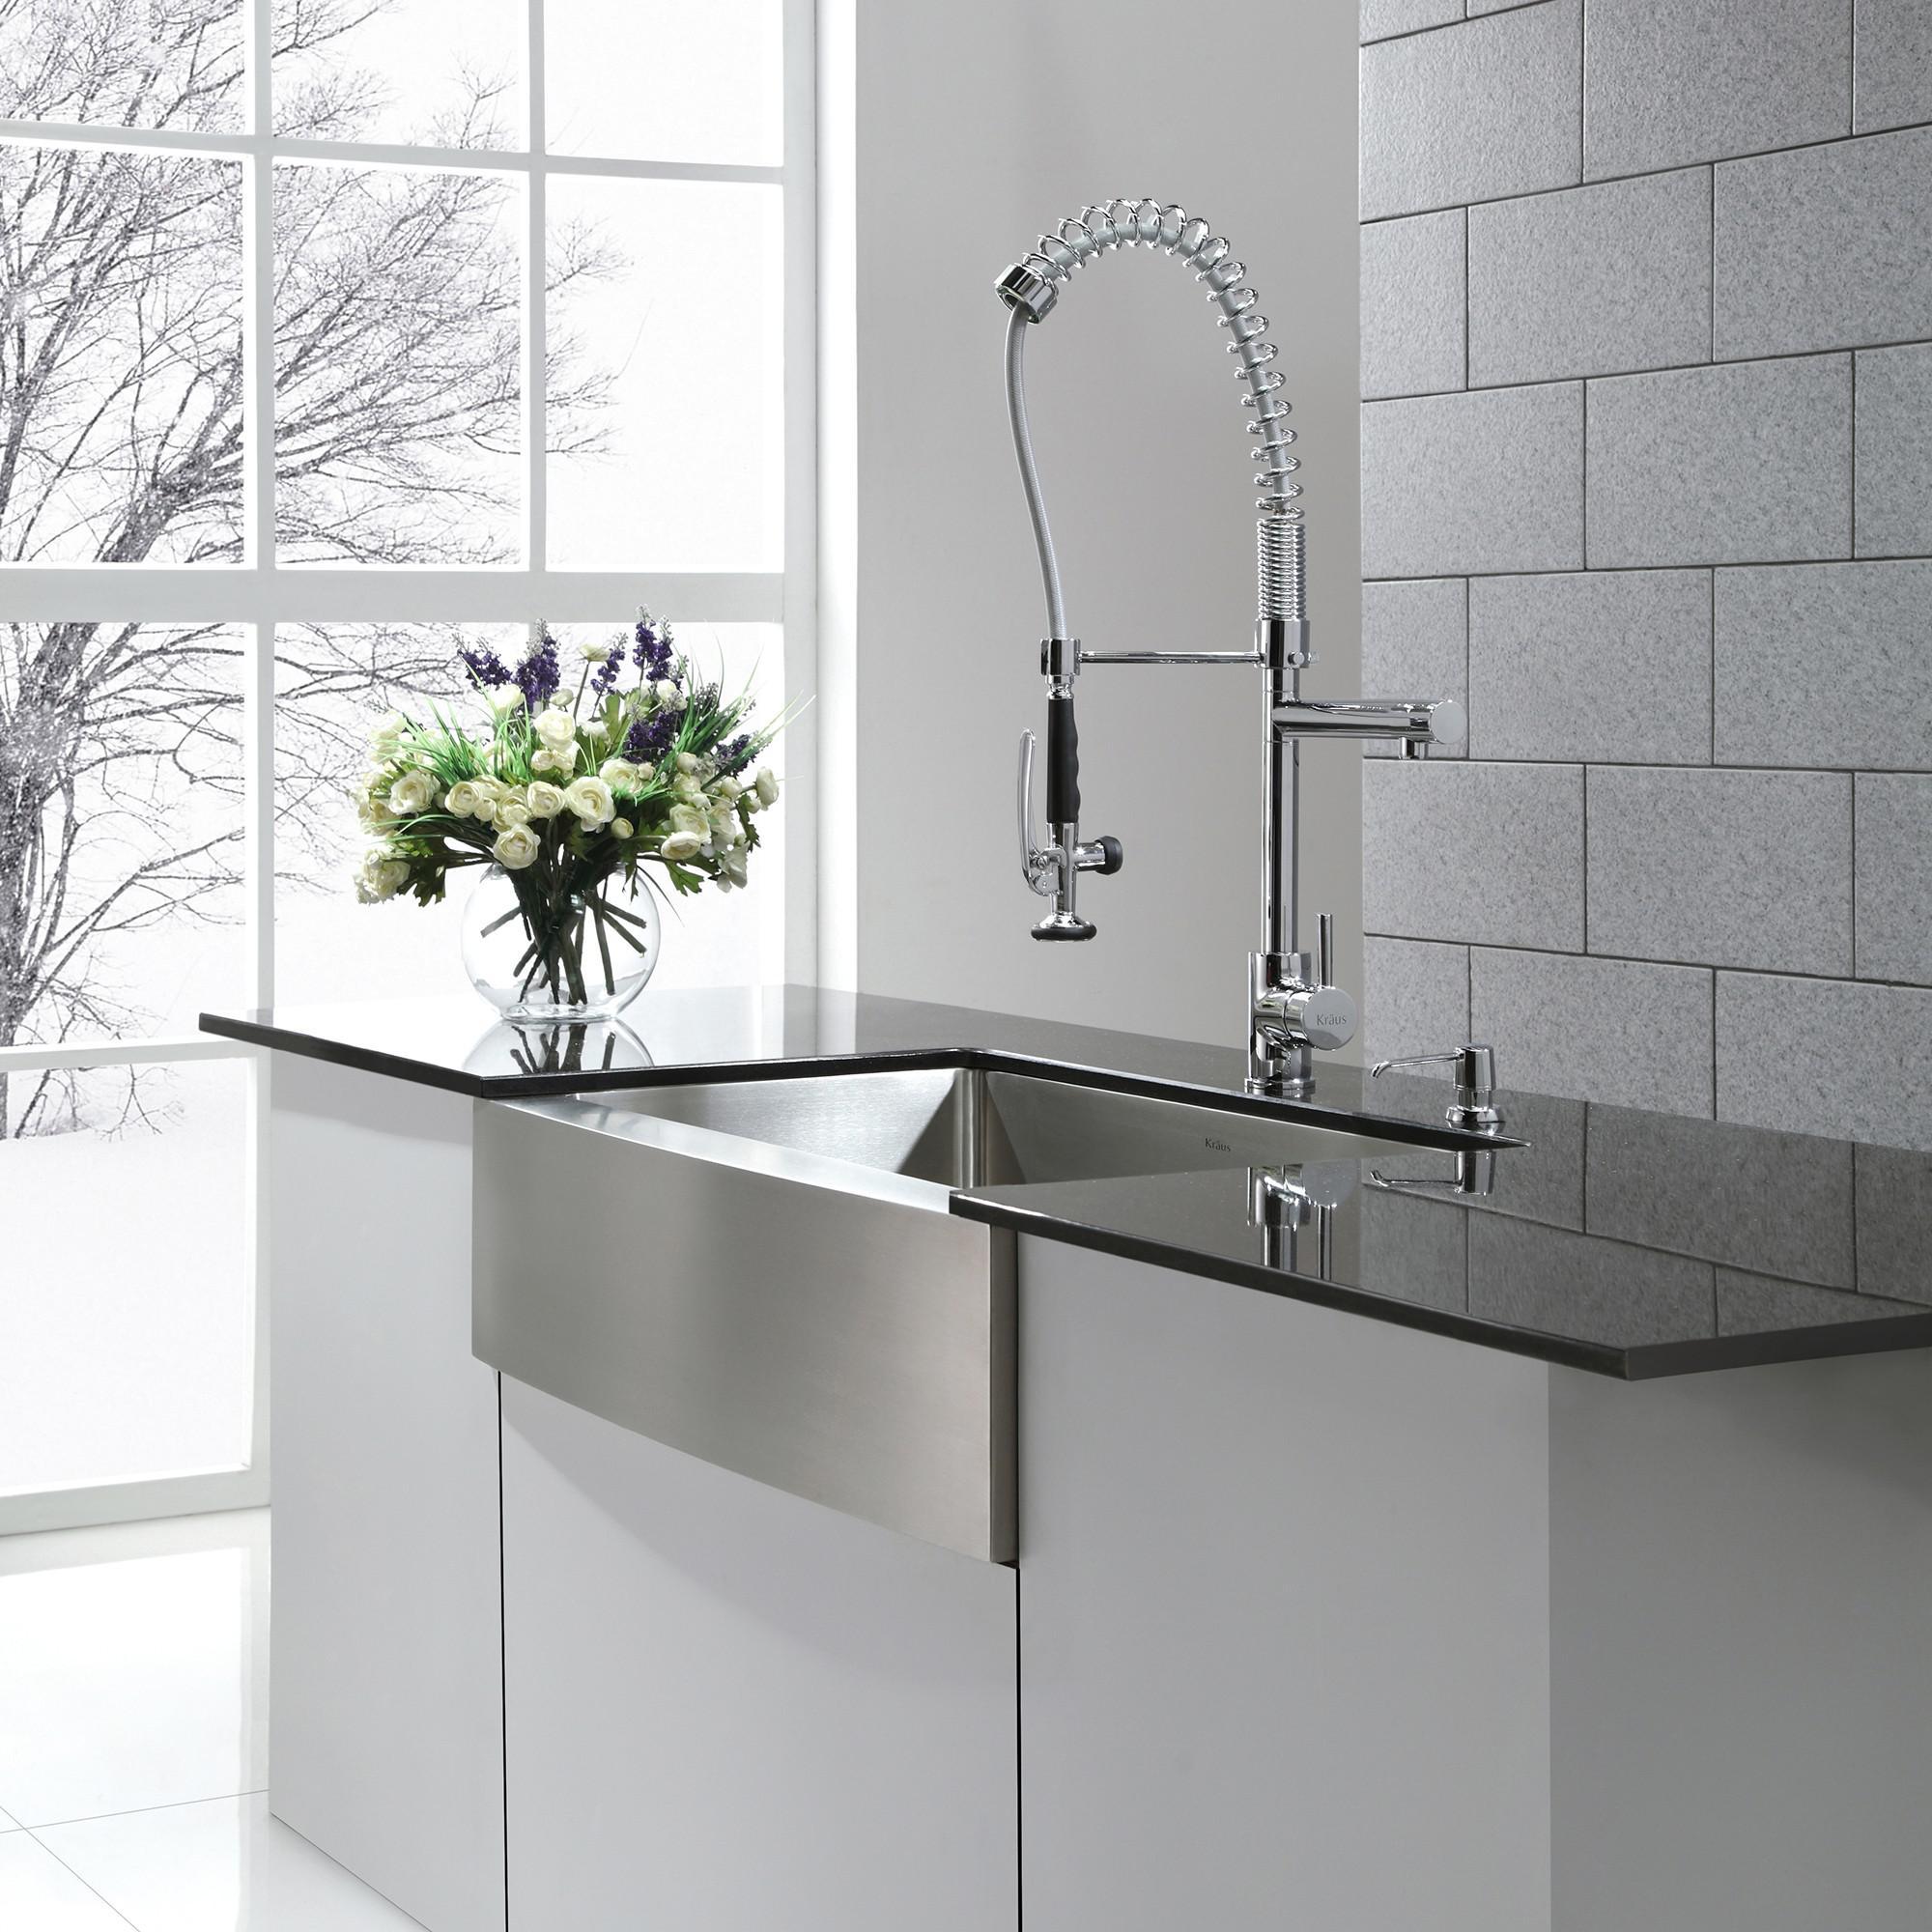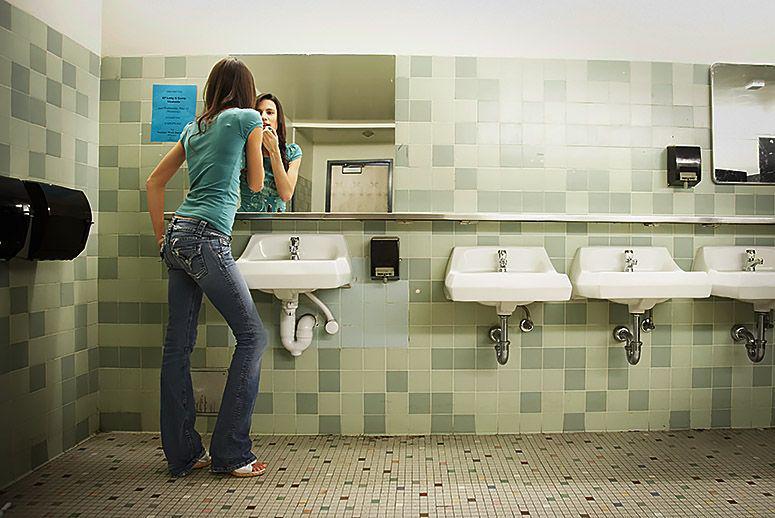The first image is the image on the left, the second image is the image on the right. Analyze the images presented: Is the assertion "Multiple pump-top dispensers can be seen sitting on top of surfaces instead of mounted." valid? Answer yes or no. No. 